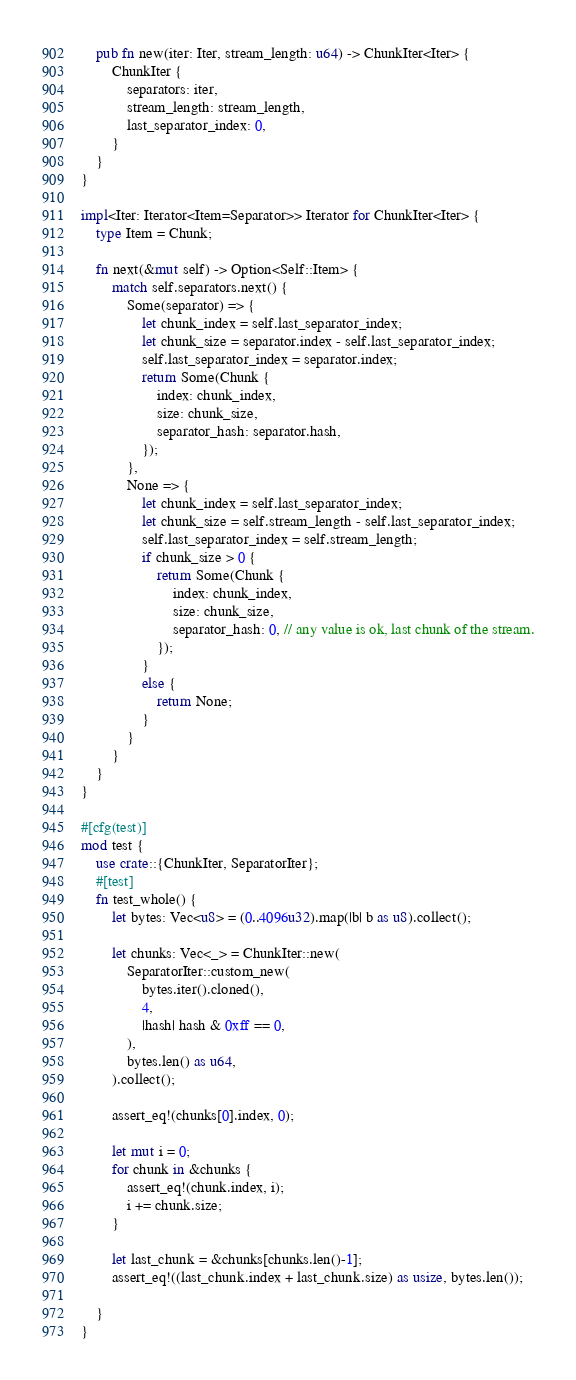<code> <loc_0><loc_0><loc_500><loc_500><_Rust_>    pub fn new(iter: Iter, stream_length: u64) -> ChunkIter<Iter> {
        ChunkIter {
            separators: iter,
            stream_length: stream_length,
            last_separator_index: 0,
        }
    }
}

impl<Iter: Iterator<Item=Separator>> Iterator for ChunkIter<Iter> {
    type Item = Chunk;

    fn next(&mut self) -> Option<Self::Item> {
        match self.separators.next() {
            Some(separator) => {
                let chunk_index = self.last_separator_index;
                let chunk_size = separator.index - self.last_separator_index;
                self.last_separator_index = separator.index;
                return Some(Chunk {
                    index: chunk_index,
                    size: chunk_size,
                    separator_hash: separator.hash,
                });
            },
            None => {
                let chunk_index = self.last_separator_index;
                let chunk_size = self.stream_length - self.last_separator_index;
                self.last_separator_index = self.stream_length;
                if chunk_size > 0 {
                    return Some(Chunk {
                        index: chunk_index,
                        size: chunk_size,
                        separator_hash: 0, // any value is ok, last chunk of the stream.
                    });
                }
                else {
                    return None;
                }
            }
        }
    }
}

#[cfg(test)]
mod test {
    use crate::{ChunkIter, SeparatorIter};
    #[test]
    fn test_whole() {
        let bytes: Vec<u8> = (0..4096u32).map(|b| b as u8).collect();

        let chunks: Vec<_> = ChunkIter::new(
            SeparatorIter::custom_new(
                bytes.iter().cloned(),
                4,
                |hash| hash & 0xff == 0,
            ),
            bytes.len() as u64,
        ).collect();

        assert_eq!(chunks[0].index, 0);

        let mut i = 0;
        for chunk in &chunks {
            assert_eq!(chunk.index, i);
            i += chunk.size;
        }

        let last_chunk = &chunks[chunks.len()-1];
        assert_eq!((last_chunk.index + last_chunk.size) as usize, bytes.len());

    }
}
</code> 